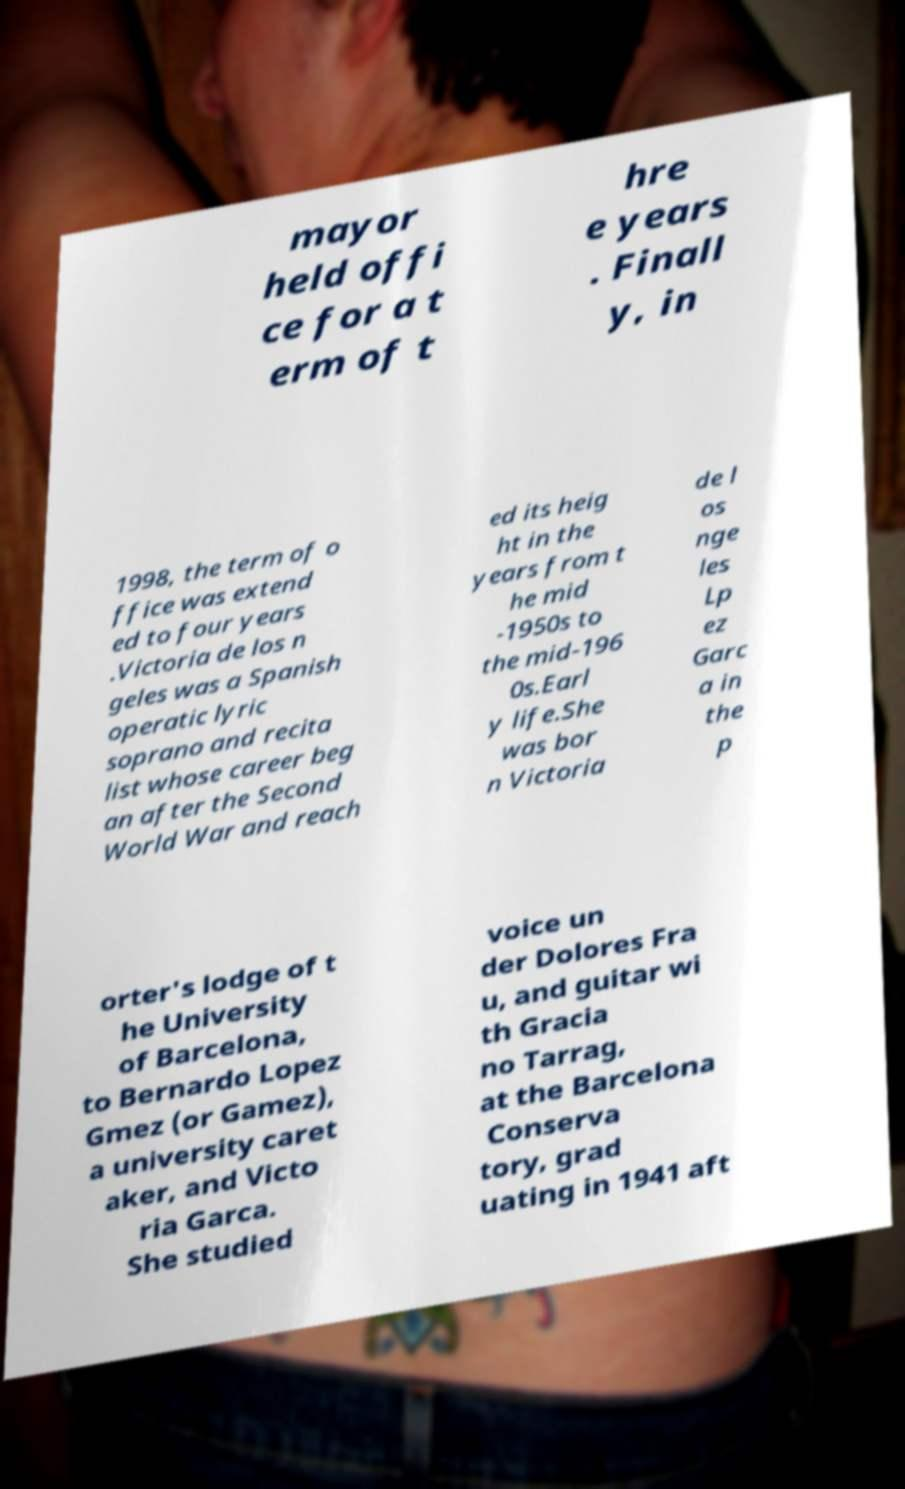I need the written content from this picture converted into text. Can you do that? mayor held offi ce for a t erm of t hre e years . Finall y, in 1998, the term of o ffice was extend ed to four years .Victoria de los n geles was a Spanish operatic lyric soprano and recita list whose career beg an after the Second World War and reach ed its heig ht in the years from t he mid -1950s to the mid-196 0s.Earl y life.She was bor n Victoria de l os nge les Lp ez Garc a in the p orter's lodge of t he University of Barcelona, to Bernardo Lopez Gmez (or Gamez), a university caret aker, and Victo ria Garca. She studied voice un der Dolores Fra u, and guitar wi th Gracia no Tarrag, at the Barcelona Conserva tory, grad uating in 1941 aft 